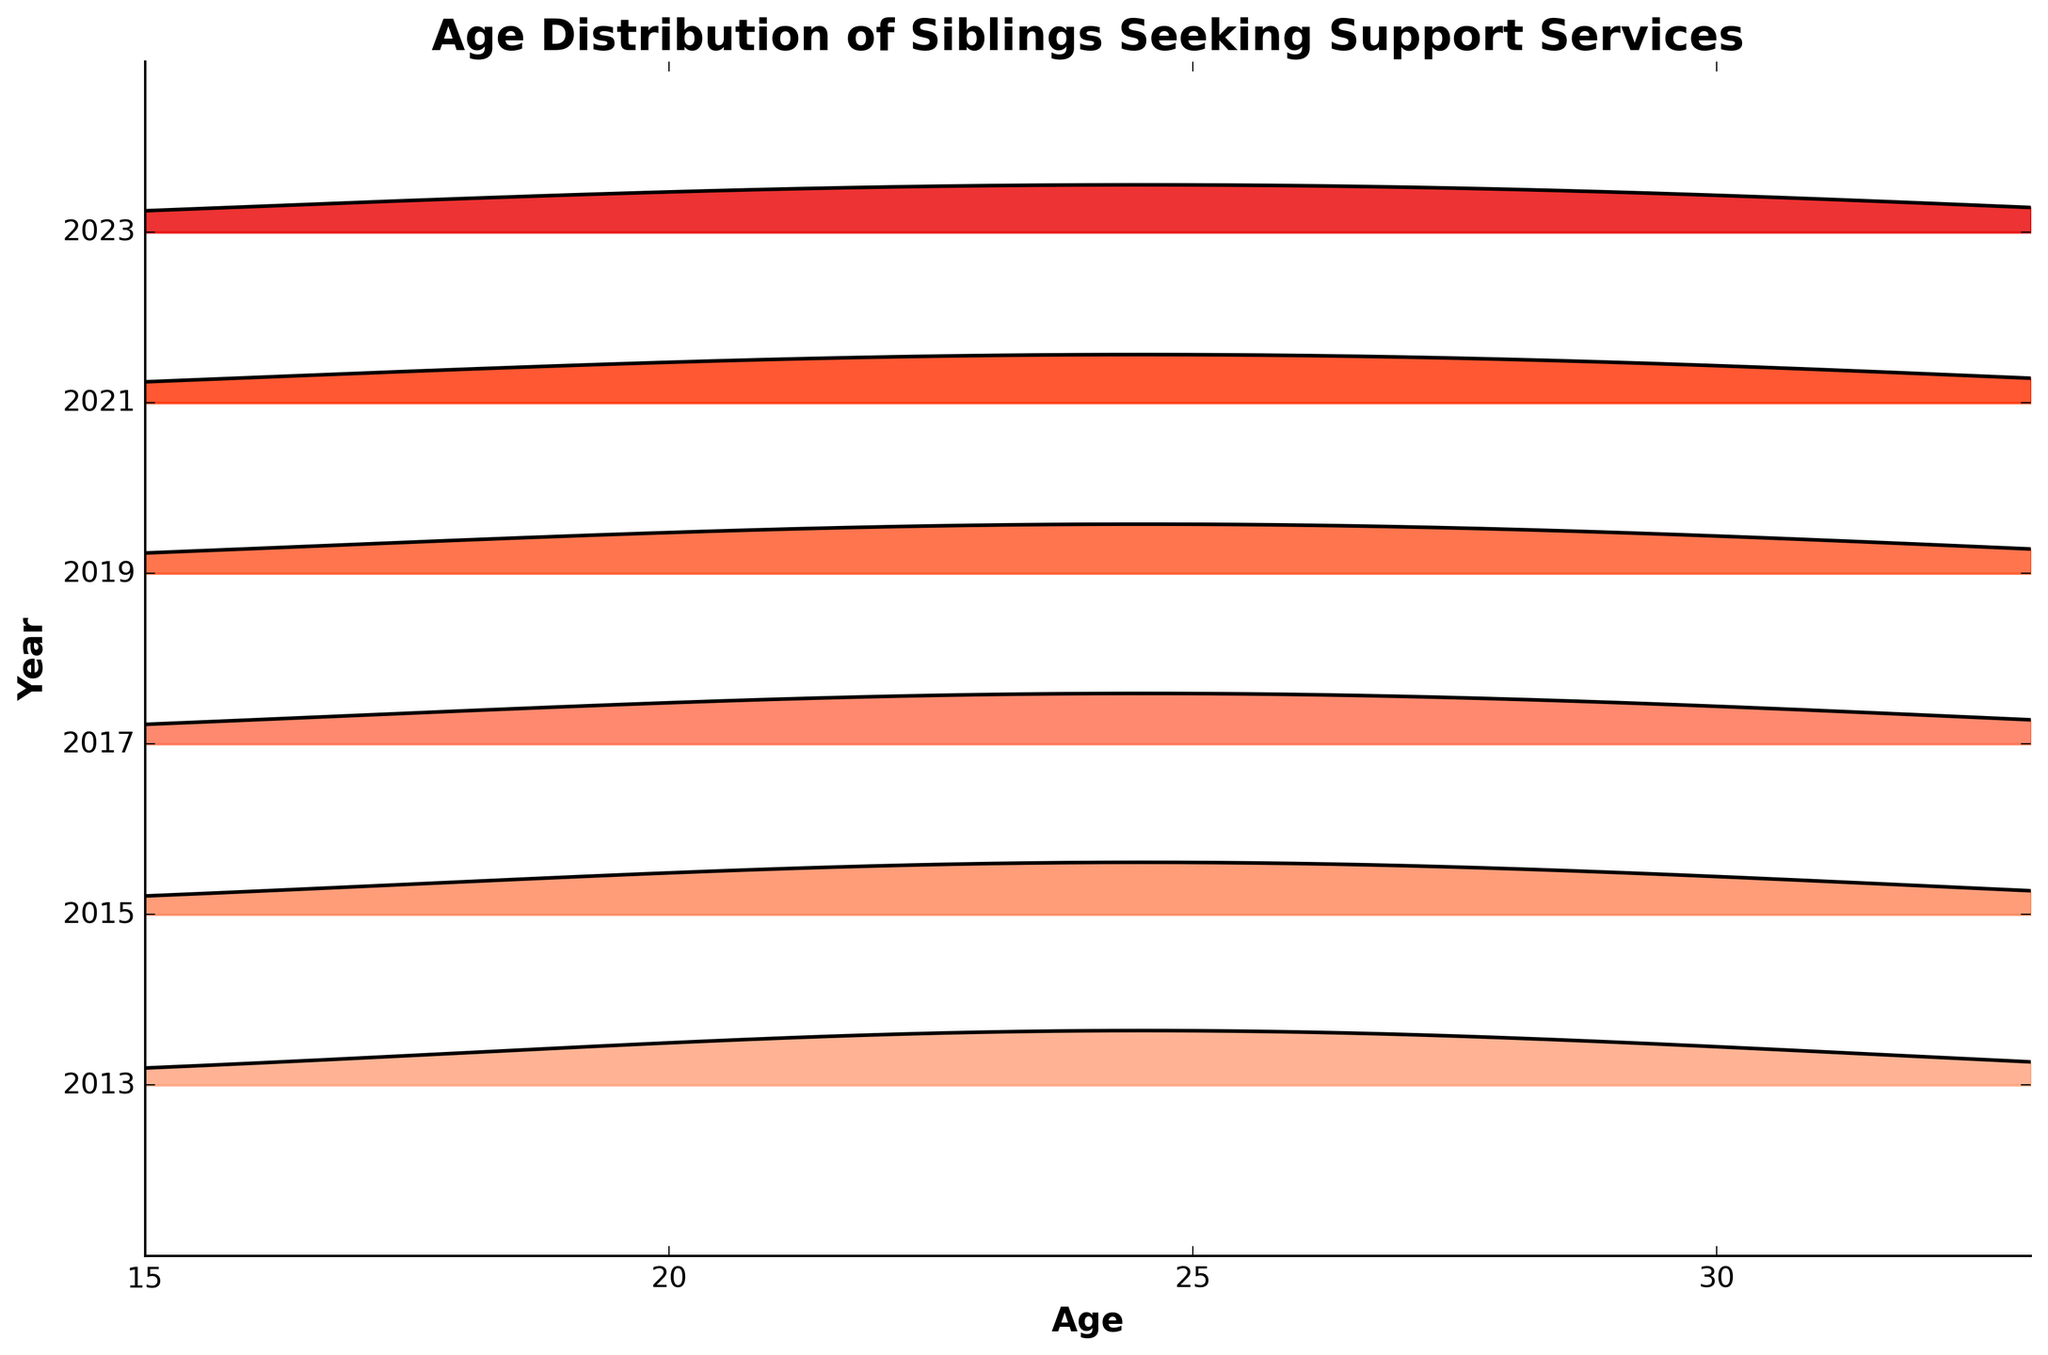what is the title of the plot? The title is usually at the top of the plot. It summarizes what the graph is about. Here, it's "Age Distribution of Siblings Seeking Support Services".
Answer: Age Distribution of Siblings Seeking Support Services Which year has the highest density of siblings aged 24? Look at the different curves for each year and identify which one is tallest at age 24. The tallest point indicates the highest density.
Answer: 2023 How does the density of siblings aged 18 change from 2013 to 2023? Compare the density values for the age 18 points across different years from 2013 to 2023. Observe how they increase or decrease.
Answer: It increases What are the y-axis labels? The y-axis labels in the plot represent the years for which the data is plotted. Read these labels directly from the y-axis in the plot.
Answer: years Which age group saw the most significant increase in density over the years? Look at the density curves for each age group over different years and find which age group's density peaks have grown the most.
Answer: 24 Compare the densities of siblings aged 30 in 2013 and 2023. Which year has a higher density? Find the densities for age 30 in the curves for 2013 and 2023. Compare them to see which is higher.
Answer: 2023 Which year had the lowest overall density for siblings aged 15? Compare the densities at age 15 across all the years. The year with the smallest peak at age 15 has the lowest density.
Answer: 2013 What's the overall trend in density for siblings aged 27 from 2013 to 2023? Observe the densities of siblings aged 27 in all years and see whether the curves increase, decrease, or stay the same over time.
Answer: It increases How are the colors used in the plot to represent different years? Assess how different colors are applied to represent the data for various years. Each year usually has its distinct color.
Answer: Different colors In which year do siblings aged 21 have the highest density? Find the peaks of the curves at age 21 for all the years, and identify which year has the highest peak.
Answer: 2023 